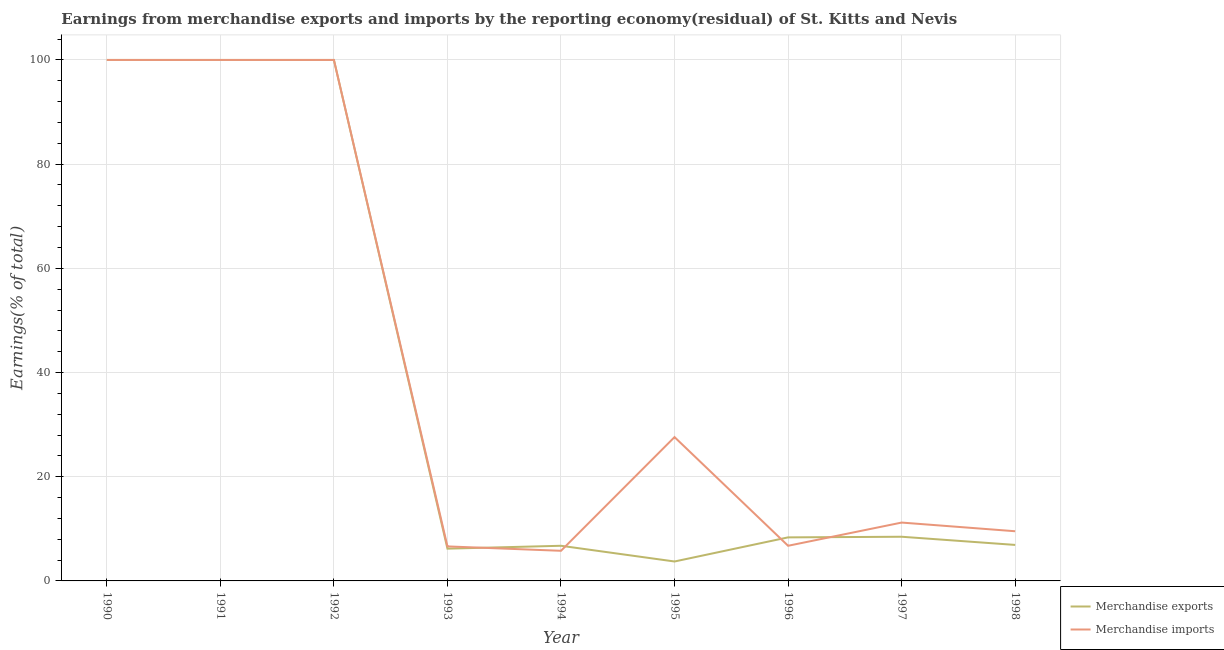How many different coloured lines are there?
Your answer should be compact. 2. Is the number of lines equal to the number of legend labels?
Your response must be concise. Yes. What is the earnings from merchandise exports in 1996?
Make the answer very short. 8.36. Across all years, what is the maximum earnings from merchandise imports?
Give a very brief answer. 100. Across all years, what is the minimum earnings from merchandise exports?
Ensure brevity in your answer.  3.73. In which year was the earnings from merchandise exports maximum?
Provide a short and direct response. 1990. In which year was the earnings from merchandise imports minimum?
Keep it short and to the point. 1994. What is the total earnings from merchandise imports in the graph?
Your response must be concise. 367.5. What is the difference between the earnings from merchandise exports in 1991 and that in 1993?
Offer a terse response. 93.81. What is the difference between the earnings from merchandise exports in 1991 and the earnings from merchandise imports in 1996?
Make the answer very short. 93.25. What is the average earnings from merchandise imports per year?
Offer a very short reply. 40.83. In how many years, is the earnings from merchandise imports greater than 76 %?
Make the answer very short. 3. What is the ratio of the earnings from merchandise imports in 1996 to that in 1997?
Your answer should be very brief. 0.6. Is the difference between the earnings from merchandise imports in 1990 and 1994 greater than the difference between the earnings from merchandise exports in 1990 and 1994?
Your answer should be very brief. Yes. What is the difference between the highest and the lowest earnings from merchandise exports?
Your answer should be very brief. 96.27. How many lines are there?
Offer a terse response. 2. What is the difference between two consecutive major ticks on the Y-axis?
Your response must be concise. 20. Does the graph contain any zero values?
Give a very brief answer. No. Does the graph contain grids?
Ensure brevity in your answer.  Yes. How many legend labels are there?
Ensure brevity in your answer.  2. What is the title of the graph?
Your response must be concise. Earnings from merchandise exports and imports by the reporting economy(residual) of St. Kitts and Nevis. Does "Taxes on profits and capital gains" appear as one of the legend labels in the graph?
Offer a terse response. No. What is the label or title of the Y-axis?
Your response must be concise. Earnings(% of total). What is the Earnings(% of total) of Merchandise imports in 1990?
Keep it short and to the point. 100. What is the Earnings(% of total) of Merchandise imports in 1991?
Your answer should be very brief. 100. What is the Earnings(% of total) in Merchandise exports in 1992?
Offer a terse response. 100. What is the Earnings(% of total) in Merchandise exports in 1993?
Provide a short and direct response. 6.19. What is the Earnings(% of total) in Merchandise imports in 1993?
Give a very brief answer. 6.62. What is the Earnings(% of total) in Merchandise exports in 1994?
Keep it short and to the point. 6.75. What is the Earnings(% of total) of Merchandise imports in 1994?
Provide a succinct answer. 5.78. What is the Earnings(% of total) in Merchandise exports in 1995?
Your answer should be very brief. 3.73. What is the Earnings(% of total) in Merchandise imports in 1995?
Your answer should be compact. 27.61. What is the Earnings(% of total) of Merchandise exports in 1996?
Offer a terse response. 8.36. What is the Earnings(% of total) in Merchandise imports in 1996?
Give a very brief answer. 6.75. What is the Earnings(% of total) of Merchandise exports in 1997?
Your answer should be very brief. 8.48. What is the Earnings(% of total) in Merchandise imports in 1997?
Make the answer very short. 11.2. What is the Earnings(% of total) of Merchandise exports in 1998?
Offer a terse response. 6.91. What is the Earnings(% of total) of Merchandise imports in 1998?
Ensure brevity in your answer.  9.54. Across all years, what is the maximum Earnings(% of total) in Merchandise exports?
Ensure brevity in your answer.  100. Across all years, what is the minimum Earnings(% of total) in Merchandise exports?
Give a very brief answer. 3.73. Across all years, what is the minimum Earnings(% of total) of Merchandise imports?
Your answer should be very brief. 5.78. What is the total Earnings(% of total) of Merchandise exports in the graph?
Your answer should be very brief. 340.42. What is the total Earnings(% of total) of Merchandise imports in the graph?
Ensure brevity in your answer.  367.5. What is the difference between the Earnings(% of total) of Merchandise exports in 1990 and that in 1993?
Your answer should be compact. 93.81. What is the difference between the Earnings(% of total) of Merchandise imports in 1990 and that in 1993?
Provide a short and direct response. 93.38. What is the difference between the Earnings(% of total) in Merchandise exports in 1990 and that in 1994?
Provide a short and direct response. 93.25. What is the difference between the Earnings(% of total) of Merchandise imports in 1990 and that in 1994?
Provide a succinct answer. 94.22. What is the difference between the Earnings(% of total) of Merchandise exports in 1990 and that in 1995?
Offer a terse response. 96.27. What is the difference between the Earnings(% of total) of Merchandise imports in 1990 and that in 1995?
Keep it short and to the point. 72.39. What is the difference between the Earnings(% of total) in Merchandise exports in 1990 and that in 1996?
Provide a succinct answer. 91.64. What is the difference between the Earnings(% of total) of Merchandise imports in 1990 and that in 1996?
Your response must be concise. 93.25. What is the difference between the Earnings(% of total) of Merchandise exports in 1990 and that in 1997?
Your response must be concise. 91.52. What is the difference between the Earnings(% of total) of Merchandise imports in 1990 and that in 1997?
Ensure brevity in your answer.  88.8. What is the difference between the Earnings(% of total) of Merchandise exports in 1990 and that in 1998?
Your response must be concise. 93.09. What is the difference between the Earnings(% of total) of Merchandise imports in 1990 and that in 1998?
Your answer should be very brief. 90.46. What is the difference between the Earnings(% of total) in Merchandise exports in 1991 and that in 1993?
Provide a succinct answer. 93.81. What is the difference between the Earnings(% of total) in Merchandise imports in 1991 and that in 1993?
Ensure brevity in your answer.  93.38. What is the difference between the Earnings(% of total) of Merchandise exports in 1991 and that in 1994?
Give a very brief answer. 93.25. What is the difference between the Earnings(% of total) in Merchandise imports in 1991 and that in 1994?
Ensure brevity in your answer.  94.22. What is the difference between the Earnings(% of total) in Merchandise exports in 1991 and that in 1995?
Make the answer very short. 96.27. What is the difference between the Earnings(% of total) in Merchandise imports in 1991 and that in 1995?
Provide a succinct answer. 72.39. What is the difference between the Earnings(% of total) in Merchandise exports in 1991 and that in 1996?
Provide a succinct answer. 91.64. What is the difference between the Earnings(% of total) of Merchandise imports in 1991 and that in 1996?
Give a very brief answer. 93.25. What is the difference between the Earnings(% of total) of Merchandise exports in 1991 and that in 1997?
Your answer should be compact. 91.52. What is the difference between the Earnings(% of total) in Merchandise imports in 1991 and that in 1997?
Your answer should be very brief. 88.8. What is the difference between the Earnings(% of total) of Merchandise exports in 1991 and that in 1998?
Make the answer very short. 93.09. What is the difference between the Earnings(% of total) in Merchandise imports in 1991 and that in 1998?
Offer a terse response. 90.46. What is the difference between the Earnings(% of total) in Merchandise exports in 1992 and that in 1993?
Ensure brevity in your answer.  93.81. What is the difference between the Earnings(% of total) of Merchandise imports in 1992 and that in 1993?
Make the answer very short. 93.38. What is the difference between the Earnings(% of total) in Merchandise exports in 1992 and that in 1994?
Your response must be concise. 93.25. What is the difference between the Earnings(% of total) in Merchandise imports in 1992 and that in 1994?
Ensure brevity in your answer.  94.22. What is the difference between the Earnings(% of total) of Merchandise exports in 1992 and that in 1995?
Provide a short and direct response. 96.27. What is the difference between the Earnings(% of total) of Merchandise imports in 1992 and that in 1995?
Provide a short and direct response. 72.39. What is the difference between the Earnings(% of total) of Merchandise exports in 1992 and that in 1996?
Ensure brevity in your answer.  91.64. What is the difference between the Earnings(% of total) of Merchandise imports in 1992 and that in 1996?
Your response must be concise. 93.25. What is the difference between the Earnings(% of total) of Merchandise exports in 1992 and that in 1997?
Your response must be concise. 91.52. What is the difference between the Earnings(% of total) in Merchandise imports in 1992 and that in 1997?
Offer a very short reply. 88.8. What is the difference between the Earnings(% of total) of Merchandise exports in 1992 and that in 1998?
Your answer should be very brief. 93.09. What is the difference between the Earnings(% of total) of Merchandise imports in 1992 and that in 1998?
Give a very brief answer. 90.46. What is the difference between the Earnings(% of total) of Merchandise exports in 1993 and that in 1994?
Offer a very short reply. -0.55. What is the difference between the Earnings(% of total) in Merchandise imports in 1993 and that in 1994?
Provide a succinct answer. 0.84. What is the difference between the Earnings(% of total) in Merchandise exports in 1993 and that in 1995?
Make the answer very short. 2.46. What is the difference between the Earnings(% of total) in Merchandise imports in 1993 and that in 1995?
Your answer should be very brief. -20.98. What is the difference between the Earnings(% of total) of Merchandise exports in 1993 and that in 1996?
Your answer should be very brief. -2.17. What is the difference between the Earnings(% of total) in Merchandise imports in 1993 and that in 1996?
Provide a short and direct response. -0.12. What is the difference between the Earnings(% of total) in Merchandise exports in 1993 and that in 1997?
Give a very brief answer. -2.29. What is the difference between the Earnings(% of total) of Merchandise imports in 1993 and that in 1997?
Your answer should be compact. -4.58. What is the difference between the Earnings(% of total) of Merchandise exports in 1993 and that in 1998?
Keep it short and to the point. -0.72. What is the difference between the Earnings(% of total) in Merchandise imports in 1993 and that in 1998?
Ensure brevity in your answer.  -2.91. What is the difference between the Earnings(% of total) of Merchandise exports in 1994 and that in 1995?
Offer a very short reply. 3.02. What is the difference between the Earnings(% of total) in Merchandise imports in 1994 and that in 1995?
Offer a terse response. -21.82. What is the difference between the Earnings(% of total) of Merchandise exports in 1994 and that in 1996?
Your response must be concise. -1.61. What is the difference between the Earnings(% of total) of Merchandise imports in 1994 and that in 1996?
Your answer should be compact. -0.96. What is the difference between the Earnings(% of total) of Merchandise exports in 1994 and that in 1997?
Give a very brief answer. -1.73. What is the difference between the Earnings(% of total) in Merchandise imports in 1994 and that in 1997?
Your answer should be very brief. -5.42. What is the difference between the Earnings(% of total) in Merchandise exports in 1994 and that in 1998?
Provide a succinct answer. -0.16. What is the difference between the Earnings(% of total) of Merchandise imports in 1994 and that in 1998?
Ensure brevity in your answer.  -3.75. What is the difference between the Earnings(% of total) in Merchandise exports in 1995 and that in 1996?
Your answer should be compact. -4.63. What is the difference between the Earnings(% of total) in Merchandise imports in 1995 and that in 1996?
Offer a terse response. 20.86. What is the difference between the Earnings(% of total) of Merchandise exports in 1995 and that in 1997?
Your response must be concise. -4.75. What is the difference between the Earnings(% of total) of Merchandise imports in 1995 and that in 1997?
Offer a terse response. 16.41. What is the difference between the Earnings(% of total) in Merchandise exports in 1995 and that in 1998?
Your answer should be compact. -3.18. What is the difference between the Earnings(% of total) of Merchandise imports in 1995 and that in 1998?
Make the answer very short. 18.07. What is the difference between the Earnings(% of total) in Merchandise exports in 1996 and that in 1997?
Offer a very short reply. -0.12. What is the difference between the Earnings(% of total) in Merchandise imports in 1996 and that in 1997?
Your answer should be compact. -4.45. What is the difference between the Earnings(% of total) in Merchandise exports in 1996 and that in 1998?
Provide a short and direct response. 1.45. What is the difference between the Earnings(% of total) of Merchandise imports in 1996 and that in 1998?
Provide a succinct answer. -2.79. What is the difference between the Earnings(% of total) of Merchandise exports in 1997 and that in 1998?
Provide a succinct answer. 1.57. What is the difference between the Earnings(% of total) of Merchandise imports in 1997 and that in 1998?
Your response must be concise. 1.67. What is the difference between the Earnings(% of total) of Merchandise exports in 1990 and the Earnings(% of total) of Merchandise imports in 1992?
Keep it short and to the point. 0. What is the difference between the Earnings(% of total) in Merchandise exports in 1990 and the Earnings(% of total) in Merchandise imports in 1993?
Ensure brevity in your answer.  93.38. What is the difference between the Earnings(% of total) in Merchandise exports in 1990 and the Earnings(% of total) in Merchandise imports in 1994?
Make the answer very short. 94.22. What is the difference between the Earnings(% of total) of Merchandise exports in 1990 and the Earnings(% of total) of Merchandise imports in 1995?
Your answer should be very brief. 72.39. What is the difference between the Earnings(% of total) of Merchandise exports in 1990 and the Earnings(% of total) of Merchandise imports in 1996?
Give a very brief answer. 93.25. What is the difference between the Earnings(% of total) in Merchandise exports in 1990 and the Earnings(% of total) in Merchandise imports in 1997?
Offer a terse response. 88.8. What is the difference between the Earnings(% of total) in Merchandise exports in 1990 and the Earnings(% of total) in Merchandise imports in 1998?
Offer a very short reply. 90.46. What is the difference between the Earnings(% of total) in Merchandise exports in 1991 and the Earnings(% of total) in Merchandise imports in 1992?
Your response must be concise. 0. What is the difference between the Earnings(% of total) in Merchandise exports in 1991 and the Earnings(% of total) in Merchandise imports in 1993?
Ensure brevity in your answer.  93.38. What is the difference between the Earnings(% of total) of Merchandise exports in 1991 and the Earnings(% of total) of Merchandise imports in 1994?
Provide a succinct answer. 94.22. What is the difference between the Earnings(% of total) of Merchandise exports in 1991 and the Earnings(% of total) of Merchandise imports in 1995?
Your answer should be compact. 72.39. What is the difference between the Earnings(% of total) in Merchandise exports in 1991 and the Earnings(% of total) in Merchandise imports in 1996?
Your answer should be very brief. 93.25. What is the difference between the Earnings(% of total) in Merchandise exports in 1991 and the Earnings(% of total) in Merchandise imports in 1997?
Ensure brevity in your answer.  88.8. What is the difference between the Earnings(% of total) of Merchandise exports in 1991 and the Earnings(% of total) of Merchandise imports in 1998?
Give a very brief answer. 90.46. What is the difference between the Earnings(% of total) in Merchandise exports in 1992 and the Earnings(% of total) in Merchandise imports in 1993?
Provide a succinct answer. 93.38. What is the difference between the Earnings(% of total) in Merchandise exports in 1992 and the Earnings(% of total) in Merchandise imports in 1994?
Provide a short and direct response. 94.22. What is the difference between the Earnings(% of total) of Merchandise exports in 1992 and the Earnings(% of total) of Merchandise imports in 1995?
Your answer should be very brief. 72.39. What is the difference between the Earnings(% of total) of Merchandise exports in 1992 and the Earnings(% of total) of Merchandise imports in 1996?
Provide a short and direct response. 93.25. What is the difference between the Earnings(% of total) in Merchandise exports in 1992 and the Earnings(% of total) in Merchandise imports in 1997?
Your answer should be very brief. 88.8. What is the difference between the Earnings(% of total) in Merchandise exports in 1992 and the Earnings(% of total) in Merchandise imports in 1998?
Provide a succinct answer. 90.46. What is the difference between the Earnings(% of total) in Merchandise exports in 1993 and the Earnings(% of total) in Merchandise imports in 1994?
Provide a short and direct response. 0.41. What is the difference between the Earnings(% of total) of Merchandise exports in 1993 and the Earnings(% of total) of Merchandise imports in 1995?
Your answer should be very brief. -21.41. What is the difference between the Earnings(% of total) in Merchandise exports in 1993 and the Earnings(% of total) in Merchandise imports in 1996?
Your answer should be compact. -0.55. What is the difference between the Earnings(% of total) of Merchandise exports in 1993 and the Earnings(% of total) of Merchandise imports in 1997?
Give a very brief answer. -5.01. What is the difference between the Earnings(% of total) of Merchandise exports in 1993 and the Earnings(% of total) of Merchandise imports in 1998?
Offer a terse response. -3.34. What is the difference between the Earnings(% of total) in Merchandise exports in 1994 and the Earnings(% of total) in Merchandise imports in 1995?
Your answer should be very brief. -20.86. What is the difference between the Earnings(% of total) in Merchandise exports in 1994 and the Earnings(% of total) in Merchandise imports in 1997?
Ensure brevity in your answer.  -4.45. What is the difference between the Earnings(% of total) in Merchandise exports in 1994 and the Earnings(% of total) in Merchandise imports in 1998?
Keep it short and to the point. -2.79. What is the difference between the Earnings(% of total) in Merchandise exports in 1995 and the Earnings(% of total) in Merchandise imports in 1996?
Offer a very short reply. -3.02. What is the difference between the Earnings(% of total) in Merchandise exports in 1995 and the Earnings(% of total) in Merchandise imports in 1997?
Make the answer very short. -7.47. What is the difference between the Earnings(% of total) in Merchandise exports in 1995 and the Earnings(% of total) in Merchandise imports in 1998?
Offer a terse response. -5.81. What is the difference between the Earnings(% of total) in Merchandise exports in 1996 and the Earnings(% of total) in Merchandise imports in 1997?
Provide a succinct answer. -2.84. What is the difference between the Earnings(% of total) in Merchandise exports in 1996 and the Earnings(% of total) in Merchandise imports in 1998?
Provide a short and direct response. -1.18. What is the difference between the Earnings(% of total) in Merchandise exports in 1997 and the Earnings(% of total) in Merchandise imports in 1998?
Provide a short and direct response. -1.06. What is the average Earnings(% of total) of Merchandise exports per year?
Your response must be concise. 37.82. What is the average Earnings(% of total) in Merchandise imports per year?
Your answer should be very brief. 40.83. In the year 1991, what is the difference between the Earnings(% of total) in Merchandise exports and Earnings(% of total) in Merchandise imports?
Provide a succinct answer. 0. In the year 1993, what is the difference between the Earnings(% of total) in Merchandise exports and Earnings(% of total) in Merchandise imports?
Keep it short and to the point. -0.43. In the year 1994, what is the difference between the Earnings(% of total) of Merchandise exports and Earnings(% of total) of Merchandise imports?
Your answer should be very brief. 0.96. In the year 1995, what is the difference between the Earnings(% of total) of Merchandise exports and Earnings(% of total) of Merchandise imports?
Give a very brief answer. -23.88. In the year 1996, what is the difference between the Earnings(% of total) of Merchandise exports and Earnings(% of total) of Merchandise imports?
Offer a very short reply. 1.61. In the year 1997, what is the difference between the Earnings(% of total) in Merchandise exports and Earnings(% of total) in Merchandise imports?
Give a very brief answer. -2.72. In the year 1998, what is the difference between the Earnings(% of total) in Merchandise exports and Earnings(% of total) in Merchandise imports?
Give a very brief answer. -2.62. What is the ratio of the Earnings(% of total) in Merchandise exports in 1990 to that in 1991?
Give a very brief answer. 1. What is the ratio of the Earnings(% of total) of Merchandise imports in 1990 to that in 1991?
Your answer should be very brief. 1. What is the ratio of the Earnings(% of total) in Merchandise exports in 1990 to that in 1992?
Provide a succinct answer. 1. What is the ratio of the Earnings(% of total) of Merchandise exports in 1990 to that in 1993?
Make the answer very short. 16.15. What is the ratio of the Earnings(% of total) in Merchandise imports in 1990 to that in 1993?
Your answer should be very brief. 15.1. What is the ratio of the Earnings(% of total) of Merchandise exports in 1990 to that in 1994?
Offer a terse response. 14.82. What is the ratio of the Earnings(% of total) in Merchandise imports in 1990 to that in 1994?
Offer a terse response. 17.29. What is the ratio of the Earnings(% of total) of Merchandise exports in 1990 to that in 1995?
Make the answer very short. 26.81. What is the ratio of the Earnings(% of total) of Merchandise imports in 1990 to that in 1995?
Make the answer very short. 3.62. What is the ratio of the Earnings(% of total) in Merchandise exports in 1990 to that in 1996?
Provide a succinct answer. 11.96. What is the ratio of the Earnings(% of total) in Merchandise imports in 1990 to that in 1996?
Offer a very short reply. 14.82. What is the ratio of the Earnings(% of total) of Merchandise exports in 1990 to that in 1997?
Offer a very short reply. 11.79. What is the ratio of the Earnings(% of total) in Merchandise imports in 1990 to that in 1997?
Offer a very short reply. 8.93. What is the ratio of the Earnings(% of total) in Merchandise exports in 1990 to that in 1998?
Offer a terse response. 14.47. What is the ratio of the Earnings(% of total) of Merchandise imports in 1990 to that in 1998?
Ensure brevity in your answer.  10.49. What is the ratio of the Earnings(% of total) of Merchandise exports in 1991 to that in 1992?
Your answer should be compact. 1. What is the ratio of the Earnings(% of total) of Merchandise imports in 1991 to that in 1992?
Make the answer very short. 1. What is the ratio of the Earnings(% of total) of Merchandise exports in 1991 to that in 1993?
Provide a succinct answer. 16.15. What is the ratio of the Earnings(% of total) in Merchandise imports in 1991 to that in 1993?
Give a very brief answer. 15.1. What is the ratio of the Earnings(% of total) in Merchandise exports in 1991 to that in 1994?
Provide a short and direct response. 14.82. What is the ratio of the Earnings(% of total) of Merchandise imports in 1991 to that in 1994?
Your answer should be compact. 17.29. What is the ratio of the Earnings(% of total) of Merchandise exports in 1991 to that in 1995?
Provide a short and direct response. 26.81. What is the ratio of the Earnings(% of total) of Merchandise imports in 1991 to that in 1995?
Ensure brevity in your answer.  3.62. What is the ratio of the Earnings(% of total) of Merchandise exports in 1991 to that in 1996?
Provide a succinct answer. 11.96. What is the ratio of the Earnings(% of total) in Merchandise imports in 1991 to that in 1996?
Your response must be concise. 14.82. What is the ratio of the Earnings(% of total) in Merchandise exports in 1991 to that in 1997?
Provide a succinct answer. 11.79. What is the ratio of the Earnings(% of total) in Merchandise imports in 1991 to that in 1997?
Ensure brevity in your answer.  8.93. What is the ratio of the Earnings(% of total) in Merchandise exports in 1991 to that in 1998?
Provide a short and direct response. 14.47. What is the ratio of the Earnings(% of total) of Merchandise imports in 1991 to that in 1998?
Your answer should be compact. 10.49. What is the ratio of the Earnings(% of total) of Merchandise exports in 1992 to that in 1993?
Give a very brief answer. 16.15. What is the ratio of the Earnings(% of total) in Merchandise imports in 1992 to that in 1993?
Keep it short and to the point. 15.1. What is the ratio of the Earnings(% of total) in Merchandise exports in 1992 to that in 1994?
Ensure brevity in your answer.  14.82. What is the ratio of the Earnings(% of total) in Merchandise imports in 1992 to that in 1994?
Your response must be concise. 17.29. What is the ratio of the Earnings(% of total) of Merchandise exports in 1992 to that in 1995?
Your answer should be compact. 26.81. What is the ratio of the Earnings(% of total) of Merchandise imports in 1992 to that in 1995?
Provide a succinct answer. 3.62. What is the ratio of the Earnings(% of total) in Merchandise exports in 1992 to that in 1996?
Make the answer very short. 11.96. What is the ratio of the Earnings(% of total) in Merchandise imports in 1992 to that in 1996?
Make the answer very short. 14.82. What is the ratio of the Earnings(% of total) in Merchandise exports in 1992 to that in 1997?
Your answer should be compact. 11.79. What is the ratio of the Earnings(% of total) in Merchandise imports in 1992 to that in 1997?
Make the answer very short. 8.93. What is the ratio of the Earnings(% of total) of Merchandise exports in 1992 to that in 1998?
Offer a terse response. 14.47. What is the ratio of the Earnings(% of total) of Merchandise imports in 1992 to that in 1998?
Make the answer very short. 10.49. What is the ratio of the Earnings(% of total) of Merchandise exports in 1993 to that in 1994?
Make the answer very short. 0.92. What is the ratio of the Earnings(% of total) in Merchandise imports in 1993 to that in 1994?
Provide a short and direct response. 1.15. What is the ratio of the Earnings(% of total) of Merchandise exports in 1993 to that in 1995?
Your response must be concise. 1.66. What is the ratio of the Earnings(% of total) in Merchandise imports in 1993 to that in 1995?
Make the answer very short. 0.24. What is the ratio of the Earnings(% of total) in Merchandise exports in 1993 to that in 1996?
Keep it short and to the point. 0.74. What is the ratio of the Earnings(% of total) of Merchandise imports in 1993 to that in 1996?
Offer a very short reply. 0.98. What is the ratio of the Earnings(% of total) in Merchandise exports in 1993 to that in 1997?
Your answer should be compact. 0.73. What is the ratio of the Earnings(% of total) of Merchandise imports in 1993 to that in 1997?
Provide a succinct answer. 0.59. What is the ratio of the Earnings(% of total) of Merchandise exports in 1993 to that in 1998?
Give a very brief answer. 0.9. What is the ratio of the Earnings(% of total) of Merchandise imports in 1993 to that in 1998?
Your answer should be compact. 0.69. What is the ratio of the Earnings(% of total) of Merchandise exports in 1994 to that in 1995?
Provide a short and direct response. 1.81. What is the ratio of the Earnings(% of total) in Merchandise imports in 1994 to that in 1995?
Keep it short and to the point. 0.21. What is the ratio of the Earnings(% of total) of Merchandise exports in 1994 to that in 1996?
Your response must be concise. 0.81. What is the ratio of the Earnings(% of total) in Merchandise imports in 1994 to that in 1996?
Offer a terse response. 0.86. What is the ratio of the Earnings(% of total) of Merchandise exports in 1994 to that in 1997?
Your answer should be compact. 0.8. What is the ratio of the Earnings(% of total) of Merchandise imports in 1994 to that in 1997?
Offer a very short reply. 0.52. What is the ratio of the Earnings(% of total) in Merchandise exports in 1994 to that in 1998?
Give a very brief answer. 0.98. What is the ratio of the Earnings(% of total) of Merchandise imports in 1994 to that in 1998?
Your answer should be compact. 0.61. What is the ratio of the Earnings(% of total) in Merchandise exports in 1995 to that in 1996?
Ensure brevity in your answer.  0.45. What is the ratio of the Earnings(% of total) of Merchandise imports in 1995 to that in 1996?
Give a very brief answer. 4.09. What is the ratio of the Earnings(% of total) in Merchandise exports in 1995 to that in 1997?
Keep it short and to the point. 0.44. What is the ratio of the Earnings(% of total) of Merchandise imports in 1995 to that in 1997?
Keep it short and to the point. 2.46. What is the ratio of the Earnings(% of total) of Merchandise exports in 1995 to that in 1998?
Your response must be concise. 0.54. What is the ratio of the Earnings(% of total) in Merchandise imports in 1995 to that in 1998?
Make the answer very short. 2.9. What is the ratio of the Earnings(% of total) of Merchandise exports in 1996 to that in 1997?
Make the answer very short. 0.99. What is the ratio of the Earnings(% of total) of Merchandise imports in 1996 to that in 1997?
Give a very brief answer. 0.6. What is the ratio of the Earnings(% of total) in Merchandise exports in 1996 to that in 1998?
Ensure brevity in your answer.  1.21. What is the ratio of the Earnings(% of total) of Merchandise imports in 1996 to that in 1998?
Offer a very short reply. 0.71. What is the ratio of the Earnings(% of total) in Merchandise exports in 1997 to that in 1998?
Make the answer very short. 1.23. What is the ratio of the Earnings(% of total) of Merchandise imports in 1997 to that in 1998?
Make the answer very short. 1.17. What is the difference between the highest and the second highest Earnings(% of total) in Merchandise imports?
Your answer should be very brief. 0. What is the difference between the highest and the lowest Earnings(% of total) in Merchandise exports?
Provide a succinct answer. 96.27. What is the difference between the highest and the lowest Earnings(% of total) in Merchandise imports?
Offer a terse response. 94.22. 